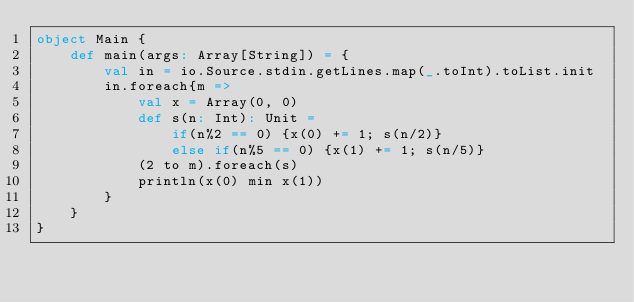<code> <loc_0><loc_0><loc_500><loc_500><_Scala_>object Main {
    def main(args: Array[String]) = {
        val in = io.Source.stdin.getLines.map(_.toInt).toList.init
        in.foreach{m =>
            val x = Array(0, 0)
            def s(n: Int): Unit =
                if(n%2 == 0) {x(0) += 1; s(n/2)}
                else if(n%5 == 0) {x(1) += 1; s(n/5)}
            (2 to m).foreach(s)
            println(x(0) min x(1))
        }
    }
}</code> 